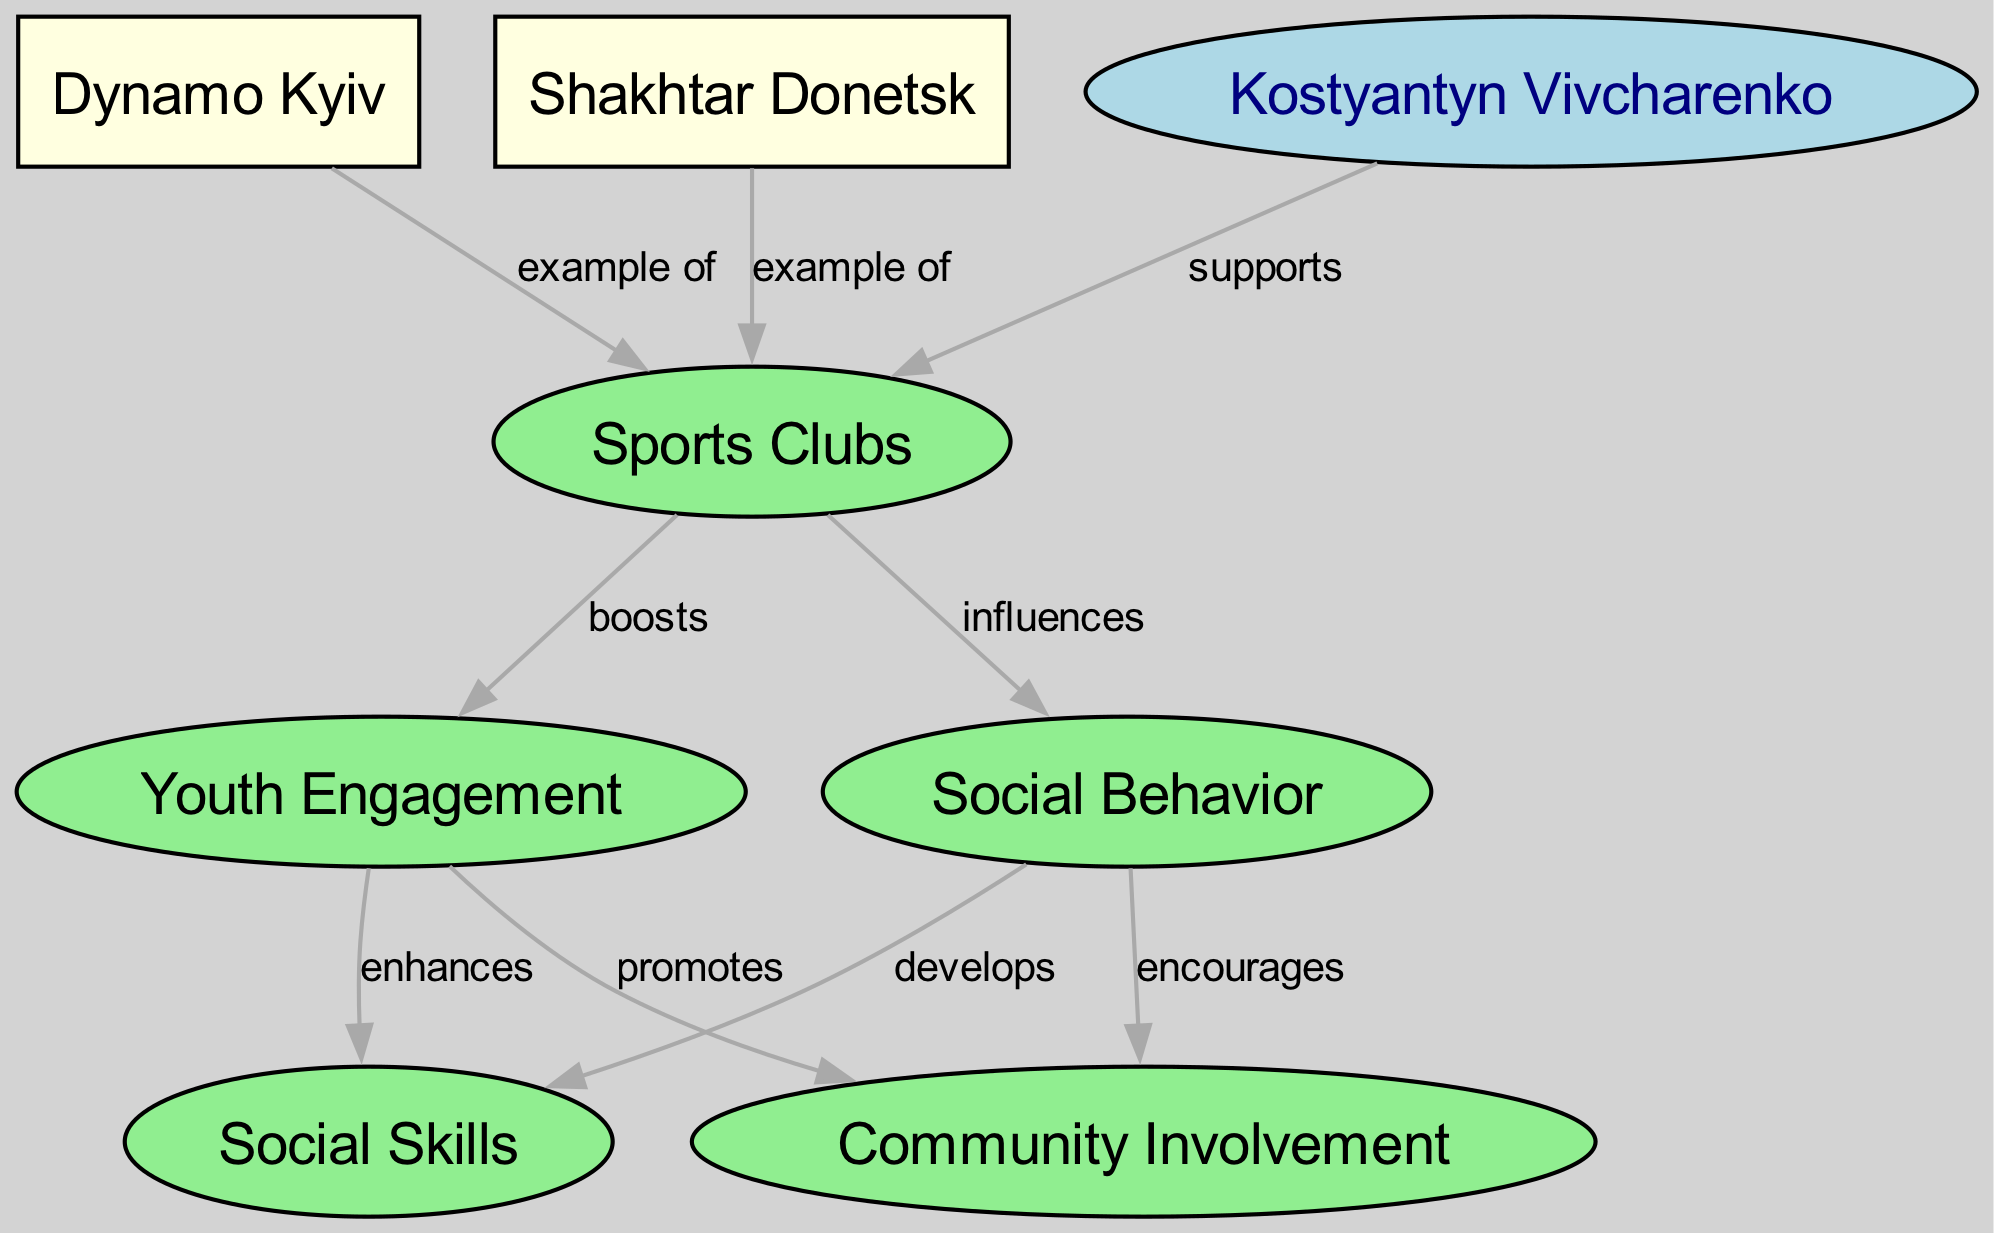What are the two examples of sports clubs listed in the diagram? The diagram contains two nodes labeled as examples of sports clubs: Dynamo Kyiv and Shakhtar Donetsk. These clubs are connected to the "Sports Clubs" node with the label "example of."
Answer: Dynamo Kyiv, Shakhtar Donetsk How many total nodes are in the diagram? The diagram contains a total of eight nodes as listed: Sports Clubs, Youth Engagement, Social Behavior, Dynamo Kyiv, Shakhtar Donetsk, Social Skills, Community Involvement, and Kostyantyn Vivcharenko.
Answer: 8 Which node is supported by Kostyantyn Vivcharenko? The diagram indicates that Kostyantyn Vivcharenko connects to the "Sports Clubs" node with the label "supports." Therefore, he supports the development of sports clubs.
Answer: Sports Clubs What is the relationship between Youth Engagement and Social Skills? The diagram shows that Youth Engagement "enhances" Social Skills, indicating a positive influence of youth engagement on the development of these skills.
Answer: enhances How does Social Behavior relate to Community Involvement? In the diagram, Social Behavior "encourages" Community Involvement. This means that positive social behavior fosters greater involvement within the community.
Answer: encourages Which sports club is the example that supports Youth Engagement? Both Dynamo Kyiv and Shakhtar Donetsk are labeled as examples of sports clubs, but the diagram specifically does not indicate one that supports Youth Engagement, rather, it shows that Sports Clubs boost Youth Engagement directly.
Answer: Sports Clubs What influences both Youth Engagement and Social Behavior? The diagram illustrates that "Sports Clubs" influence both Youth Engagement and Social Behavior, indicating that sports clubs have a dual role in impacting these areas among youth.
Answer: Sports Clubs Which node develops Social Skills? The diagram indicates that Social Behavior "develops" Social Skills, meaning that engaging in positive social behavior contributes to the improvement of social skills.
Answer: Social Behavior 